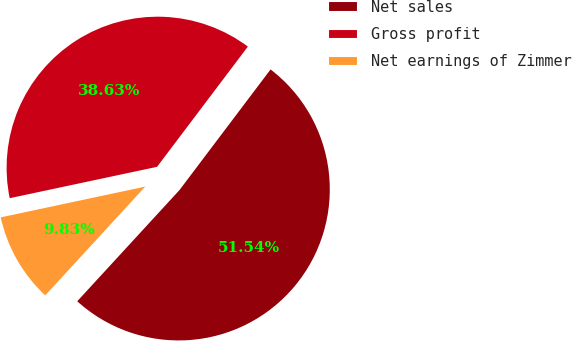<chart> <loc_0><loc_0><loc_500><loc_500><pie_chart><fcel>Net sales<fcel>Gross profit<fcel>Net earnings of Zimmer<nl><fcel>51.54%<fcel>38.63%<fcel>9.83%<nl></chart> 